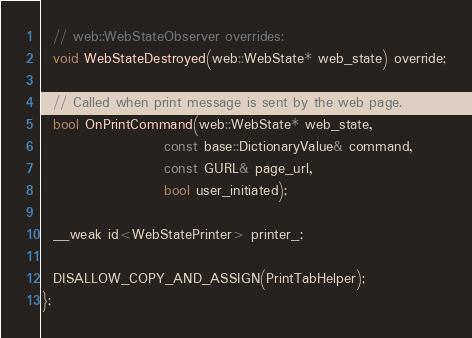<code> <loc_0><loc_0><loc_500><loc_500><_C_>
  // web::WebStateObserver overrides:
  void WebStateDestroyed(web::WebState* web_state) override;

  // Called when print message is sent by the web page.
  bool OnPrintCommand(web::WebState* web_state,
                      const base::DictionaryValue& command,
                      const GURL& page_url,
                      bool user_initiated);

  __weak id<WebStatePrinter> printer_;

  DISALLOW_COPY_AND_ASSIGN(PrintTabHelper);
};
</code> 